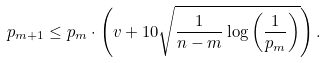<formula> <loc_0><loc_0><loc_500><loc_500>p _ { m + 1 } \leq p _ { m } \cdot \left ( v + 1 0 \sqrt { \frac { 1 } { n - m } \log \left ( \frac { 1 } { p _ { m } } \right ) } \right ) .</formula> 